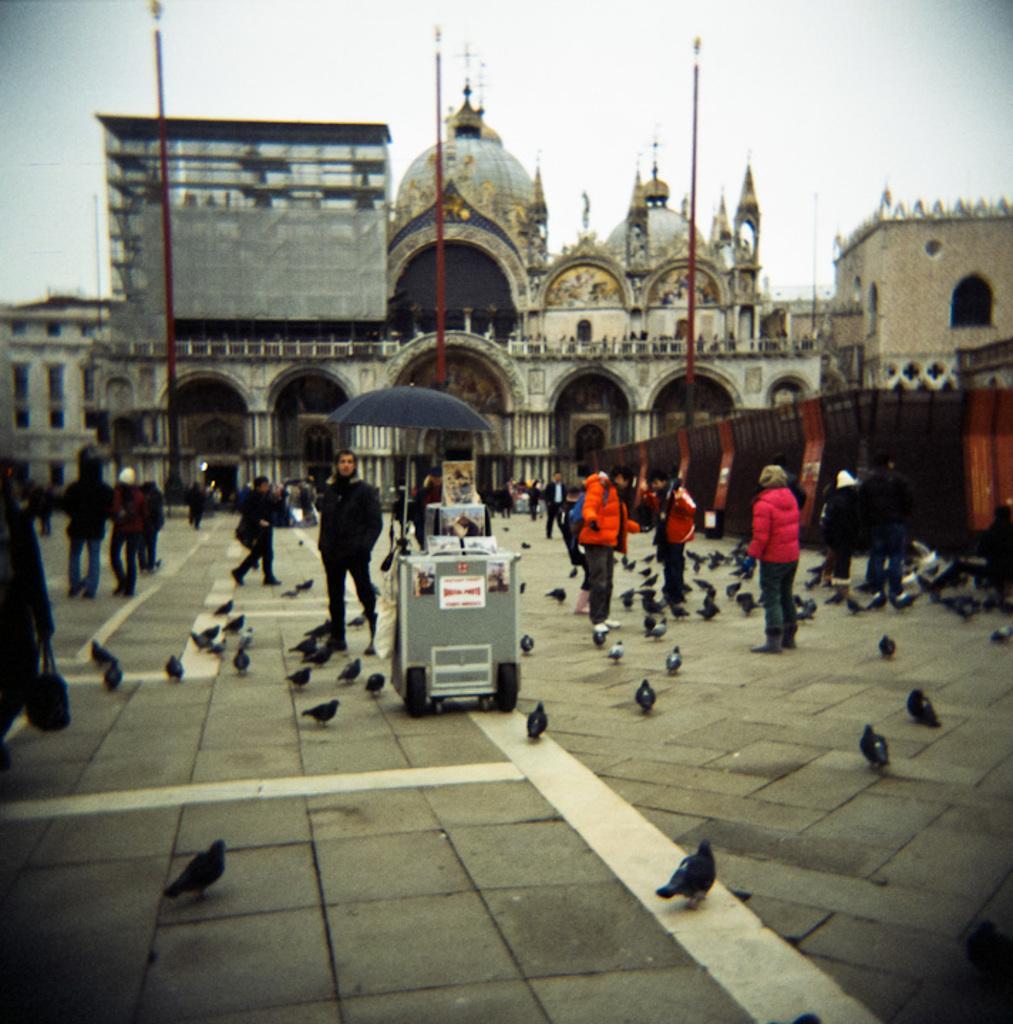Could you give a brief overview of what you see in this image? In this image I can see some birds. I can see some people. In the background, I can see the building. 